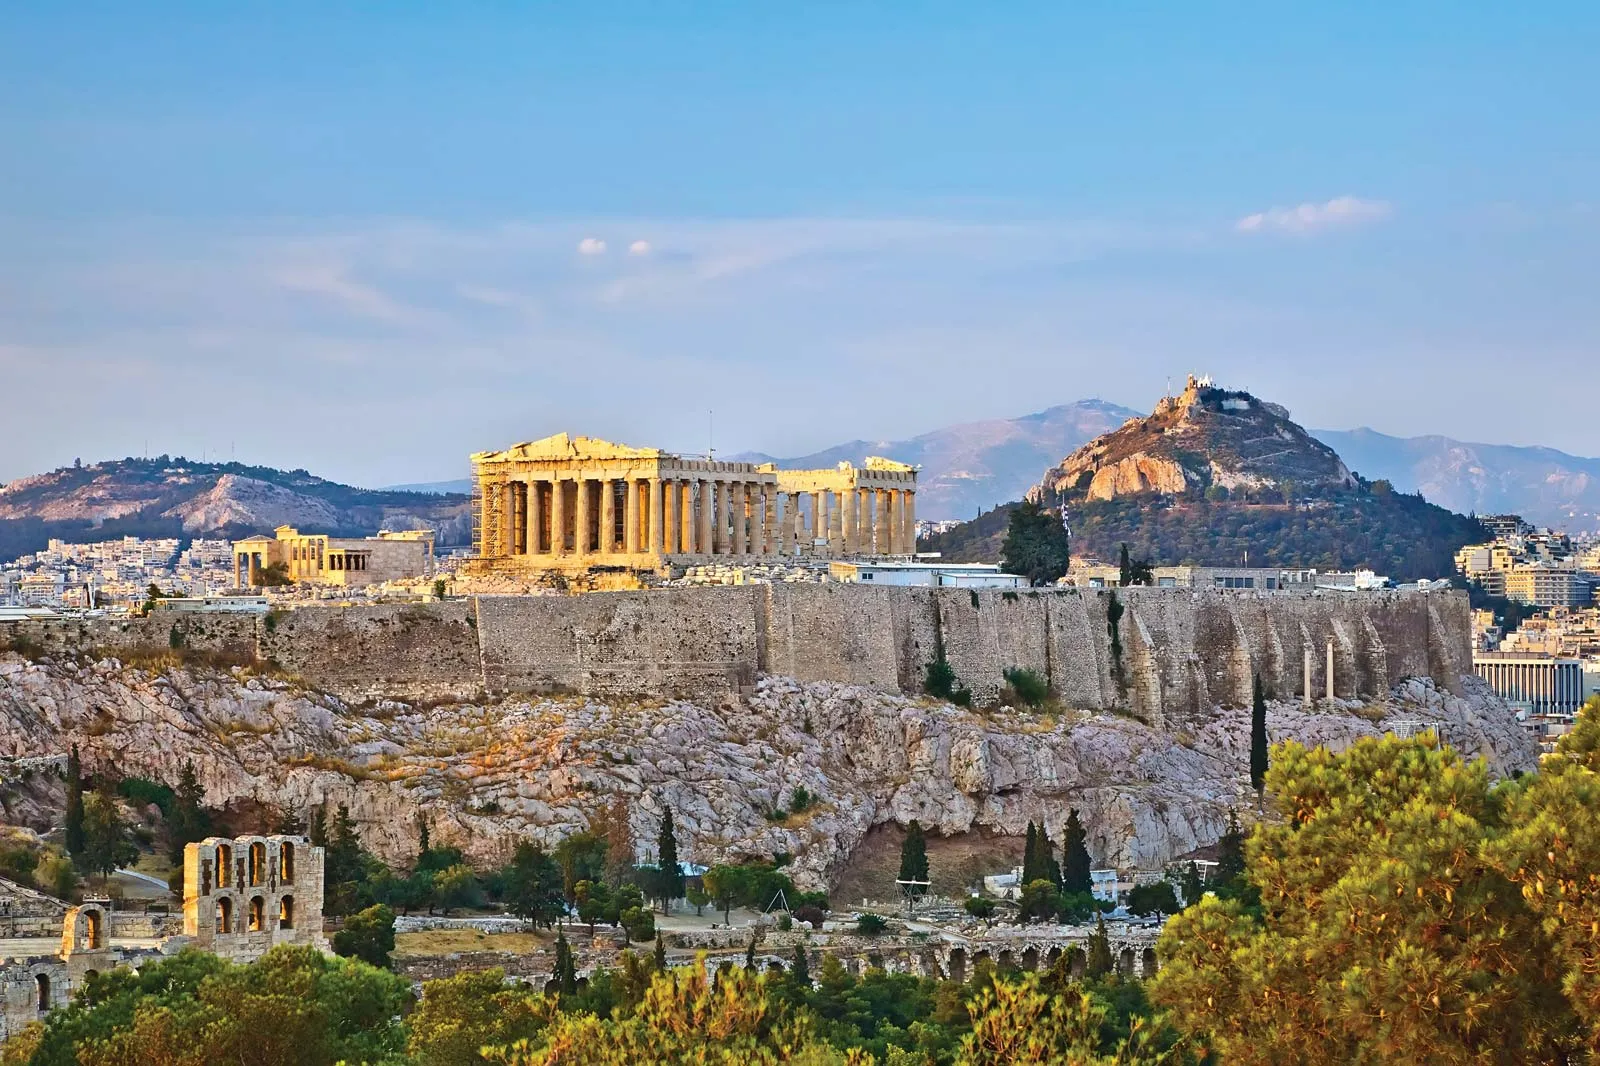Can you create a fictional story set around this place? In a time when the Acropolis was not just a historical monument but a centerpiece of a thriving city, a young aspiring sculptor named Lysandra lived in Athens. One night, as she worked late in her modest studio beneath the watchful gaze of the Parthenon, a comet streaked across the sky. The following day, an elderly priestess visited her, claiming that Athena herself had chosen Lysandra to create a new statue for the temple. Overwhelmed with honor and responsibility, Lysandra immersed herself in the project. As weeks turned into months, the city buzzed with curiosity and anticipation. Lysandra's dedication turned into obsession, and she sculpted with an intensity fueled by divine inspiration. Finally, the day arrived when the statue was unveiled. It depicted Athena not only as a goddess of war and wisdom but also with a serene, nurturing disposition reflecting Lysandra's perception of divinity. The city of Athens was awestruck, and the statue became a symbol of a new era of prosperity, creativity, and peace under Athena’s guidance. 